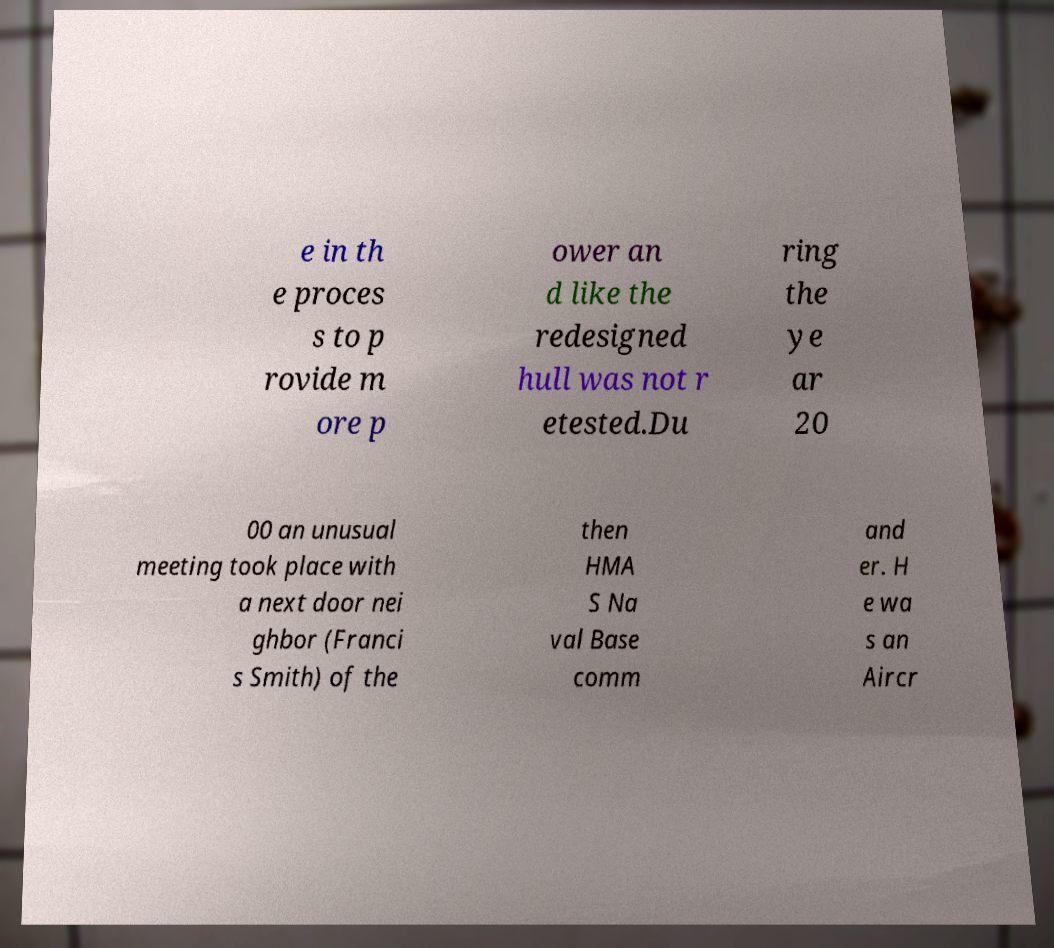Please read and relay the text visible in this image. What does it say? e in th e proces s to p rovide m ore p ower an d like the redesigned hull was not r etested.Du ring the ye ar 20 00 an unusual meeting took place with a next door nei ghbor (Franci s Smith) of the then HMA S Na val Base comm and er. H e wa s an Aircr 